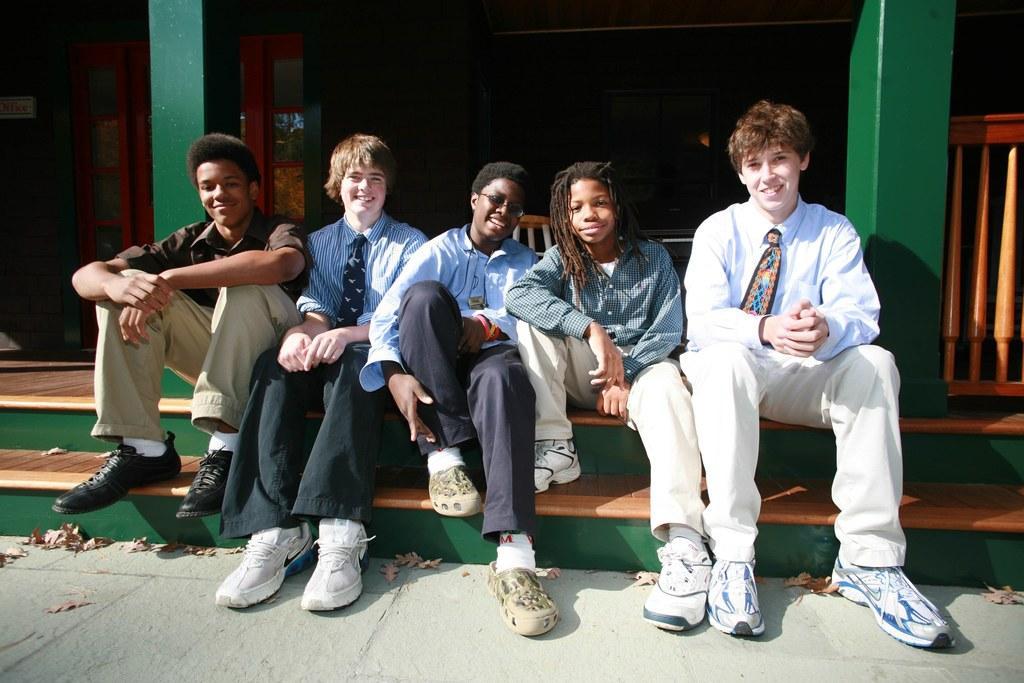Please provide a concise description of this image. In this image there are persons sitting and smiling and there are dry leaves on the ground. In the background there are cupboards and there are pillars and there is a railing and there is an object which is white and brown in colour. 